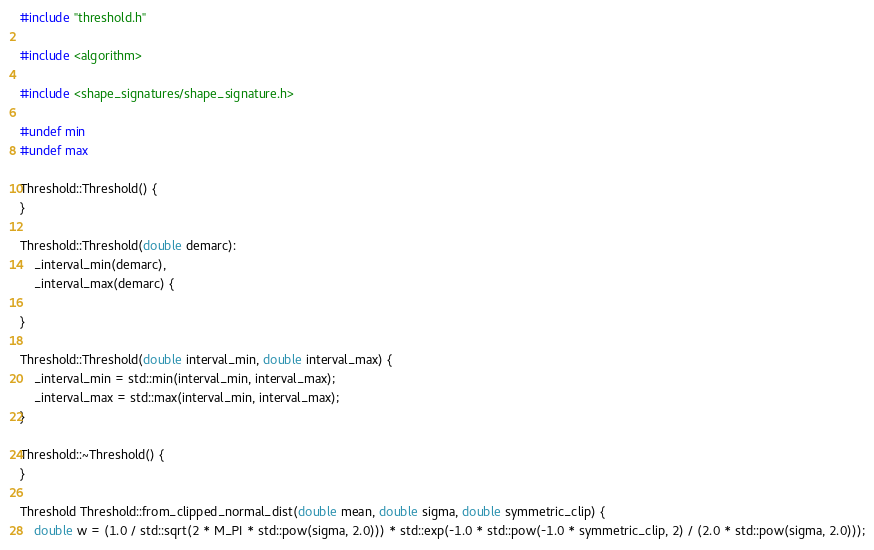<code> <loc_0><loc_0><loc_500><loc_500><_C++_>#include "threshold.h"

#include <algorithm>

#include <shape_signatures/shape_signature.h>

#undef min
#undef max

Threshold::Threshold() {
}

Threshold::Threshold(double demarc): 
	_interval_min(demarc), 
	_interval_max(demarc) {

}

Threshold::Threshold(double interval_min, double interval_max) {
	_interval_min = std::min(interval_min, interval_max);
	_interval_max = std::max(interval_min, interval_max);
}

Threshold::~Threshold() {
}

Threshold Threshold::from_clipped_normal_dist(double mean, double sigma, double symmetric_clip) {
	double w = (1.0 / std::sqrt(2 * M_PI * std::pow(sigma, 2.0))) * std::exp(-1.0 * std::pow(-1.0 * symmetric_clip, 2) / (2.0 * std::pow(sigma, 2.0)));</code> 